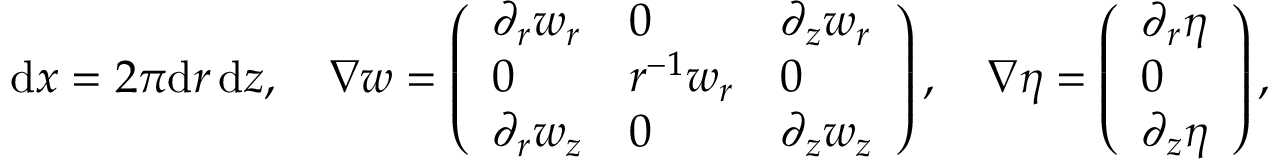Convert formula to latex. <formula><loc_0><loc_0><loc_500><loc_500>\begin{array} { r } { \, d x = 2 \pi d r \, d z , \quad \nabla w = \left ( \begin{array} { l l l } { \partial _ { r } w _ { r } } & { 0 } & { \partial _ { z } w _ { r } } \\ { 0 } & { r ^ { - 1 } w _ { r } } & { 0 } \\ { \partial _ { r } w _ { z } } & { 0 } & { \partial _ { z } w _ { z } } \end{array} \right ) , \quad \nabla \eta = \left ( \begin{array} { l } { \partial _ { r } \eta } \\ { 0 } \\ { \partial _ { z } \eta } \end{array} \right ) , } \end{array}</formula> 